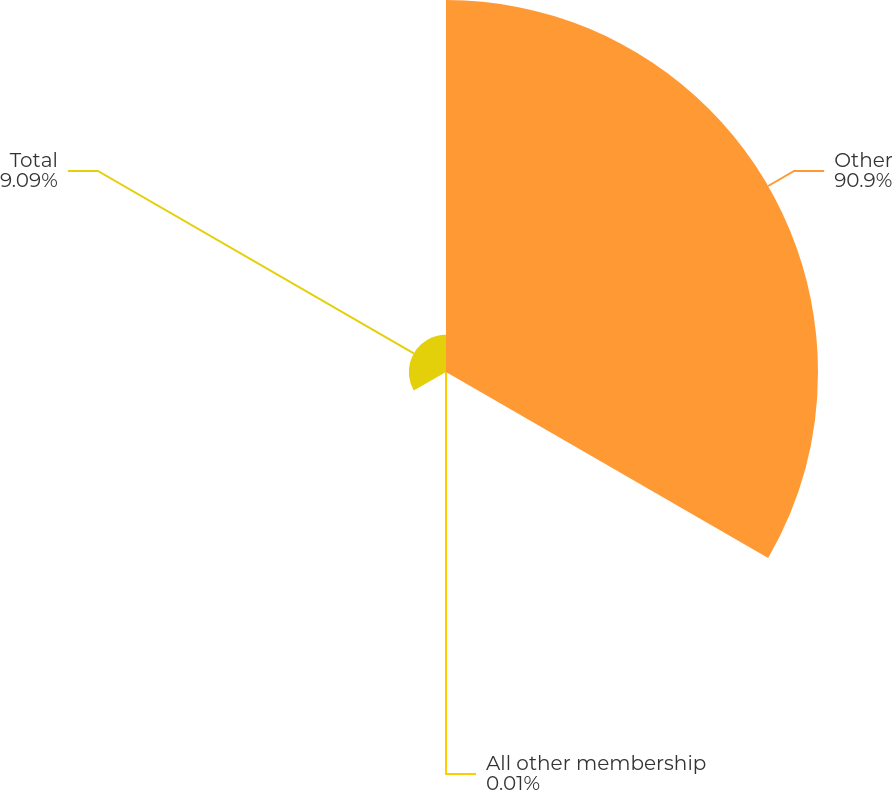<chart> <loc_0><loc_0><loc_500><loc_500><pie_chart><fcel>Other<fcel>All other membership<fcel>Total<nl><fcel>90.9%<fcel>0.01%<fcel>9.09%<nl></chart> 